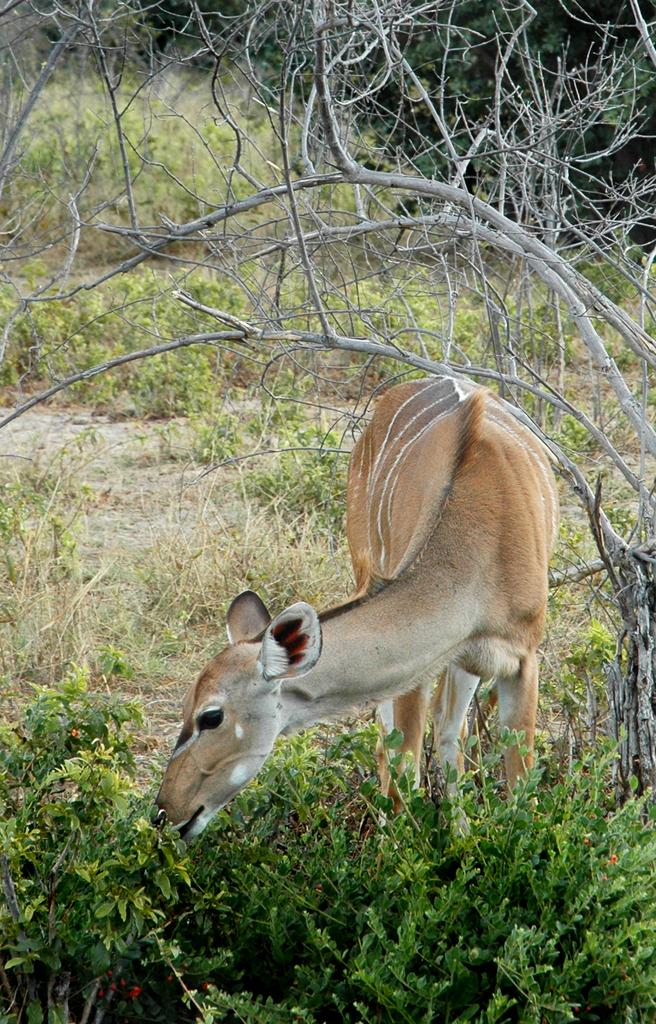What type of animal can be seen in the image? There is an animal in the image, but its specific type cannot be determined from the provided facts. What is the animal doing in the image? The animal is eating leaves of a plant in the image. What can be observed on the ground in the image? There are many plants on the ground in the image. What is visible at the top of the image? There are stems of a tree visible at the top of the image. Is there a house in the image? There is no mention of a house in the provided facts, so it cannot be determined if one is present in the image. 